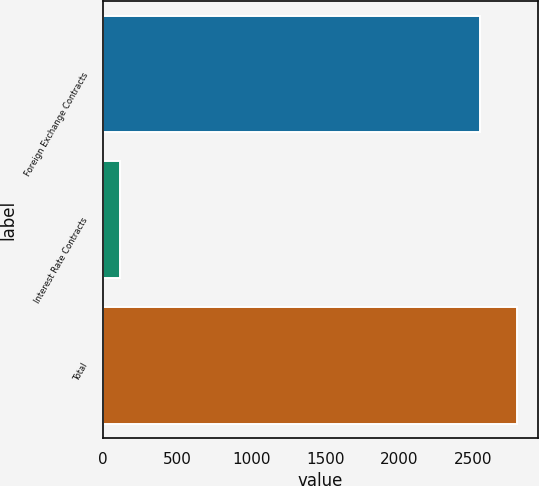Convert chart to OTSL. <chart><loc_0><loc_0><loc_500><loc_500><bar_chart><fcel>Foreign Exchange Contracts<fcel>Interest Rate Contracts<fcel>Total<nl><fcel>2541.8<fcel>111.1<fcel>2795.98<nl></chart> 